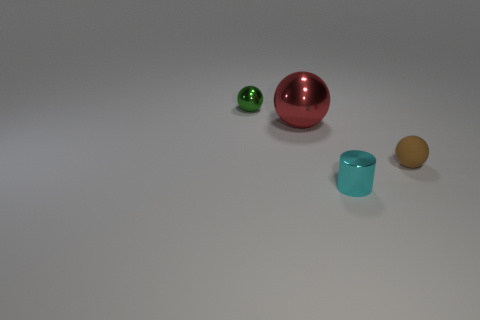How many objects are either small objects in front of the tiny green ball or green metallic balls behind the cylinder?
Provide a short and direct response. 3. Are there an equal number of cyan cylinders that are on the left side of the red ball and cylinders?
Your response must be concise. No. There is a metal object behind the red thing; is it the same size as the matte object right of the small green shiny object?
Offer a terse response. Yes. How many other objects are there of the same size as the brown matte thing?
Keep it short and to the point. 2. Are there any metal spheres left of the small metallic thing in front of the tiny thing that is on the right side of the cyan shiny cylinder?
Your answer should be very brief. Yes. Is there any other thing that is the same color as the matte sphere?
Make the answer very short. No. There is a object in front of the small rubber object; how big is it?
Provide a succinct answer. Small. What size is the object in front of the small sphere to the right of the small sphere that is left of the red thing?
Your response must be concise. Small. There is a small metallic thing in front of the small thing that is left of the cyan thing; what is its color?
Offer a very short reply. Cyan. What material is the green object that is the same shape as the red object?
Give a very brief answer. Metal. 